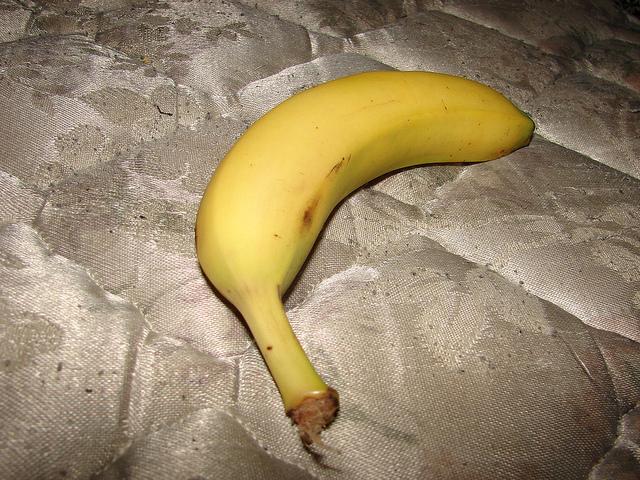What is the name of this fruit?
Be succinct. Banana. What color is the banana?
Quick response, please. Yellow. Is the banana ripe?
Concise answer only. Yes. 